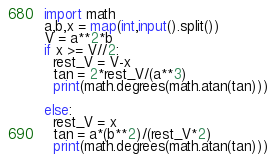Convert code to text. <code><loc_0><loc_0><loc_500><loc_500><_Python_>import math
a,b,x = map(int,input().split())
V = a**2*b
if x >= V//2:
  rest_V = V-x
  tan = 2*rest_V/(a**3)
  print(math.degrees(math.atan(tan)))
  
else:
  rest_V = x
  tan = a*(b**2)/(rest_V*2)
  print(math.degrees(math.atan(tan)))
</code> 